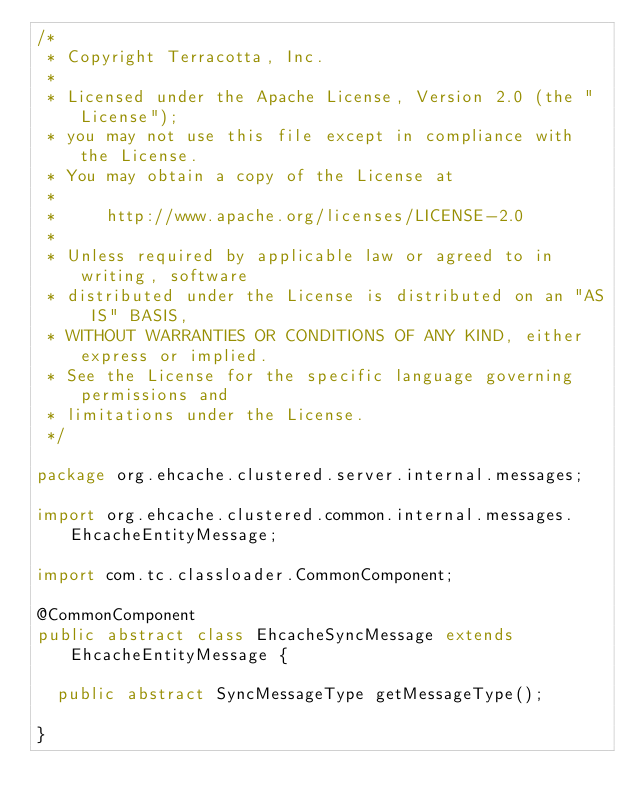Convert code to text. <code><loc_0><loc_0><loc_500><loc_500><_Java_>/*
 * Copyright Terracotta, Inc.
 *
 * Licensed under the Apache License, Version 2.0 (the "License");
 * you may not use this file except in compliance with the License.
 * You may obtain a copy of the License at
 *
 *     http://www.apache.org/licenses/LICENSE-2.0
 *
 * Unless required by applicable law or agreed to in writing, software
 * distributed under the License is distributed on an "AS IS" BASIS,
 * WITHOUT WARRANTIES OR CONDITIONS OF ANY KIND, either express or implied.
 * See the License for the specific language governing permissions and
 * limitations under the License.
 */

package org.ehcache.clustered.server.internal.messages;

import org.ehcache.clustered.common.internal.messages.EhcacheEntityMessage;

import com.tc.classloader.CommonComponent;

@CommonComponent
public abstract class EhcacheSyncMessage extends EhcacheEntityMessage {

  public abstract SyncMessageType getMessageType();

}
</code> 